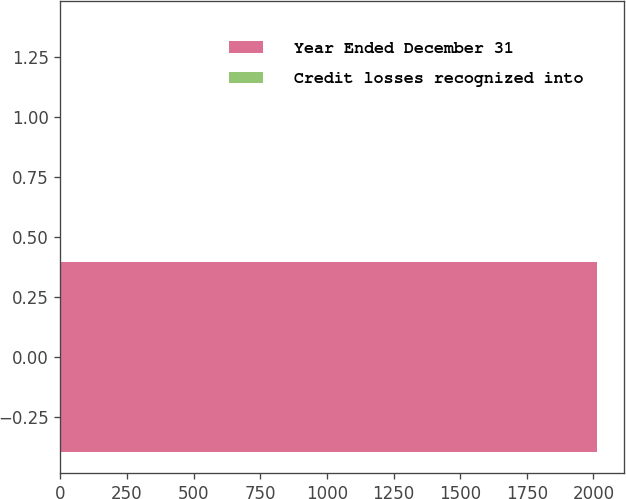Convert chart to OTSL. <chart><loc_0><loc_0><loc_500><loc_500><bar_chart><fcel>Year Ended December 31<fcel>Credit losses recognized into<nl><fcel>2014<fcel>1<nl></chart> 